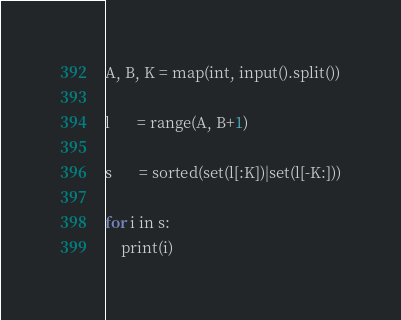<code> <loc_0><loc_0><loc_500><loc_500><_Python_>A, B, K = map(int, input().split())

l       = range(A, B+1)

s       = sorted(set(l[:K])|set(l[-K:]))

for i in s:
    print(i)</code> 